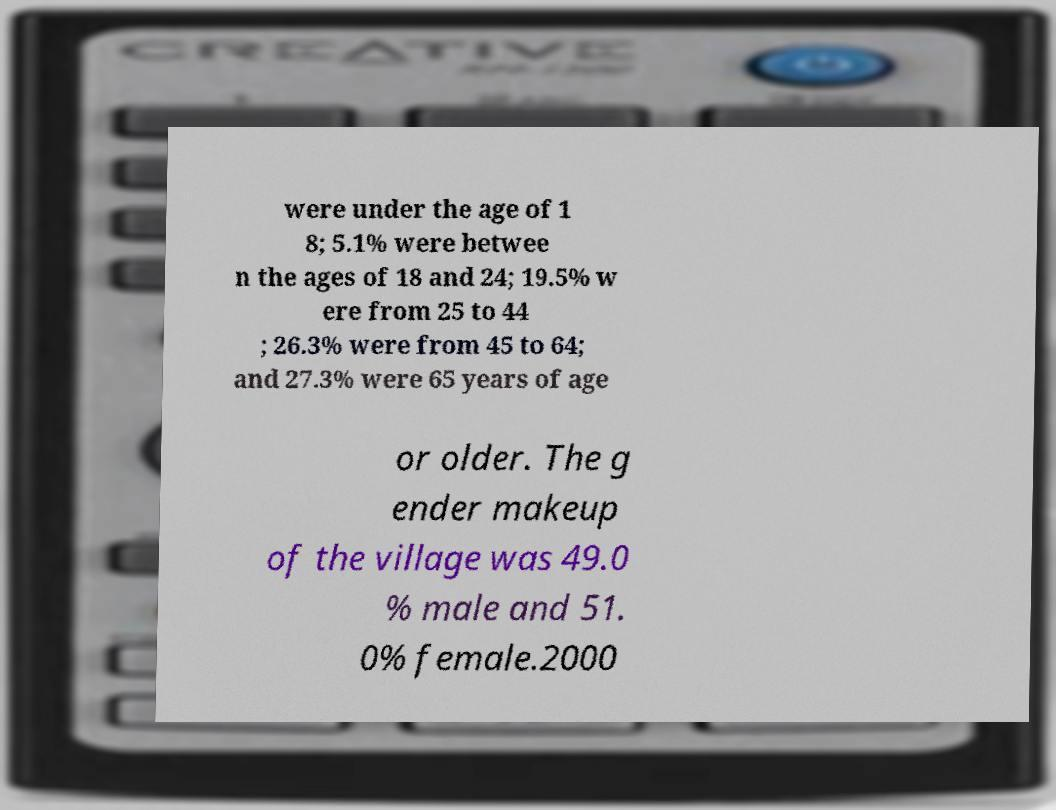There's text embedded in this image that I need extracted. Can you transcribe it verbatim? were under the age of 1 8; 5.1% were betwee n the ages of 18 and 24; 19.5% w ere from 25 to 44 ; 26.3% were from 45 to 64; and 27.3% were 65 years of age or older. The g ender makeup of the village was 49.0 % male and 51. 0% female.2000 